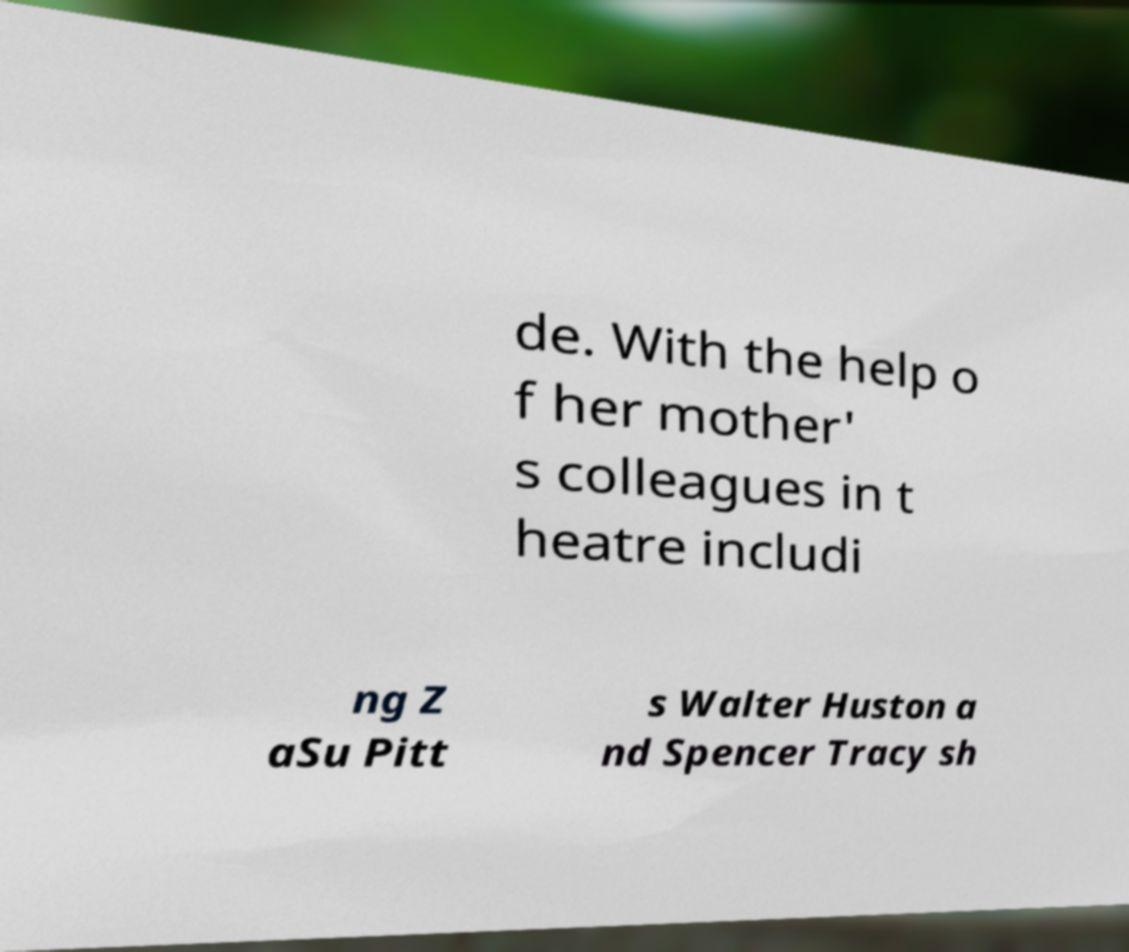Can you accurately transcribe the text from the provided image for me? de. With the help o f her mother' s colleagues in t heatre includi ng Z aSu Pitt s Walter Huston a nd Spencer Tracy sh 